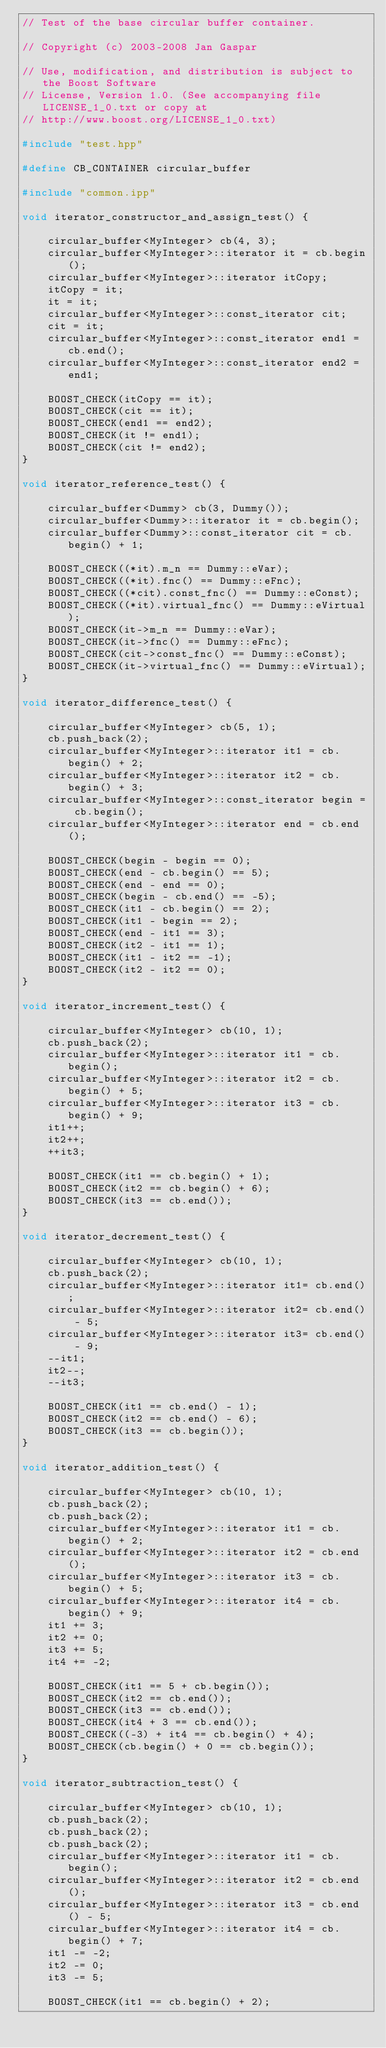<code> <loc_0><loc_0><loc_500><loc_500><_C++_>// Test of the base circular buffer container.

// Copyright (c) 2003-2008 Jan Gaspar

// Use, modification, and distribution is subject to the Boost Software
// License, Version 1.0. (See accompanying file LICENSE_1_0.txt or copy at
// http://www.boost.org/LICENSE_1_0.txt)

#include "test.hpp"

#define CB_CONTAINER circular_buffer

#include "common.ipp"

void iterator_constructor_and_assign_test() {

    circular_buffer<MyInteger> cb(4, 3);
    circular_buffer<MyInteger>::iterator it = cb.begin();
    circular_buffer<MyInteger>::iterator itCopy;
    itCopy = it;
    it = it;
    circular_buffer<MyInteger>::const_iterator cit;
    cit = it;
    circular_buffer<MyInteger>::const_iterator end1 = cb.end();
    circular_buffer<MyInteger>::const_iterator end2 = end1;

    BOOST_CHECK(itCopy == it);
    BOOST_CHECK(cit == it);
    BOOST_CHECK(end1 == end2);
    BOOST_CHECK(it != end1);
    BOOST_CHECK(cit != end2);
}

void iterator_reference_test() {

    circular_buffer<Dummy> cb(3, Dummy());
    circular_buffer<Dummy>::iterator it = cb.begin();
    circular_buffer<Dummy>::const_iterator cit = cb.begin() + 1;

    BOOST_CHECK((*it).m_n == Dummy::eVar);
    BOOST_CHECK((*it).fnc() == Dummy::eFnc);
    BOOST_CHECK((*cit).const_fnc() == Dummy::eConst);
    BOOST_CHECK((*it).virtual_fnc() == Dummy::eVirtual);
    BOOST_CHECK(it->m_n == Dummy::eVar);
    BOOST_CHECK(it->fnc() == Dummy::eFnc);
    BOOST_CHECK(cit->const_fnc() == Dummy::eConst);
    BOOST_CHECK(it->virtual_fnc() == Dummy::eVirtual);
}

void iterator_difference_test() {

    circular_buffer<MyInteger> cb(5, 1);
    cb.push_back(2);
    circular_buffer<MyInteger>::iterator it1 = cb.begin() + 2;
    circular_buffer<MyInteger>::iterator it2 = cb.begin() + 3;
    circular_buffer<MyInteger>::const_iterator begin = cb.begin();
    circular_buffer<MyInteger>::iterator end = cb.end();

    BOOST_CHECK(begin - begin == 0);
    BOOST_CHECK(end - cb.begin() == 5);
    BOOST_CHECK(end - end == 0);
    BOOST_CHECK(begin - cb.end() == -5);
    BOOST_CHECK(it1 - cb.begin() == 2);
    BOOST_CHECK(it1 - begin == 2);
    BOOST_CHECK(end - it1 == 3);
    BOOST_CHECK(it2 - it1 == 1);
    BOOST_CHECK(it1 - it2 == -1);
    BOOST_CHECK(it2 - it2 == 0);
}

void iterator_increment_test() {

    circular_buffer<MyInteger> cb(10, 1);
    cb.push_back(2);
    circular_buffer<MyInteger>::iterator it1 = cb.begin();
    circular_buffer<MyInteger>::iterator it2 = cb.begin() + 5;
    circular_buffer<MyInteger>::iterator it3 = cb.begin() + 9;
    it1++;
    it2++;
    ++it3;

    BOOST_CHECK(it1 == cb.begin() + 1);
    BOOST_CHECK(it2 == cb.begin() + 6);
    BOOST_CHECK(it3 == cb.end());
}

void iterator_decrement_test() {

    circular_buffer<MyInteger> cb(10, 1);
    cb.push_back(2);
    circular_buffer<MyInteger>::iterator it1= cb.end();
    circular_buffer<MyInteger>::iterator it2= cb.end() - 5;
    circular_buffer<MyInteger>::iterator it3= cb.end() - 9;
    --it1;
    it2--;
    --it3;

    BOOST_CHECK(it1 == cb.end() - 1);
    BOOST_CHECK(it2 == cb.end() - 6);
    BOOST_CHECK(it3 == cb.begin());
}

void iterator_addition_test() {

    circular_buffer<MyInteger> cb(10, 1);
    cb.push_back(2);
    cb.push_back(2);
    circular_buffer<MyInteger>::iterator it1 = cb.begin() + 2;
    circular_buffer<MyInteger>::iterator it2 = cb.end();
    circular_buffer<MyInteger>::iterator it3 = cb.begin() + 5;
    circular_buffer<MyInteger>::iterator it4 = cb.begin() + 9;
    it1 += 3;
    it2 += 0;
    it3 += 5;
    it4 += -2;

    BOOST_CHECK(it1 == 5 + cb.begin());
    BOOST_CHECK(it2 == cb.end());
    BOOST_CHECK(it3 == cb.end());
    BOOST_CHECK(it4 + 3 == cb.end());
    BOOST_CHECK((-3) + it4 == cb.begin() + 4);
    BOOST_CHECK(cb.begin() + 0 == cb.begin());
}

void iterator_subtraction_test() {

    circular_buffer<MyInteger> cb(10, 1);
    cb.push_back(2);
    cb.push_back(2);
    cb.push_back(2);
    circular_buffer<MyInteger>::iterator it1 = cb.begin();
    circular_buffer<MyInteger>::iterator it2 = cb.end();
    circular_buffer<MyInteger>::iterator it3 = cb.end() - 5;
    circular_buffer<MyInteger>::iterator it4 = cb.begin() + 7;
    it1 -= -2;
    it2 -= 0;
    it3 -= 5;

    BOOST_CHECK(it1 == cb.begin() + 2);</code> 